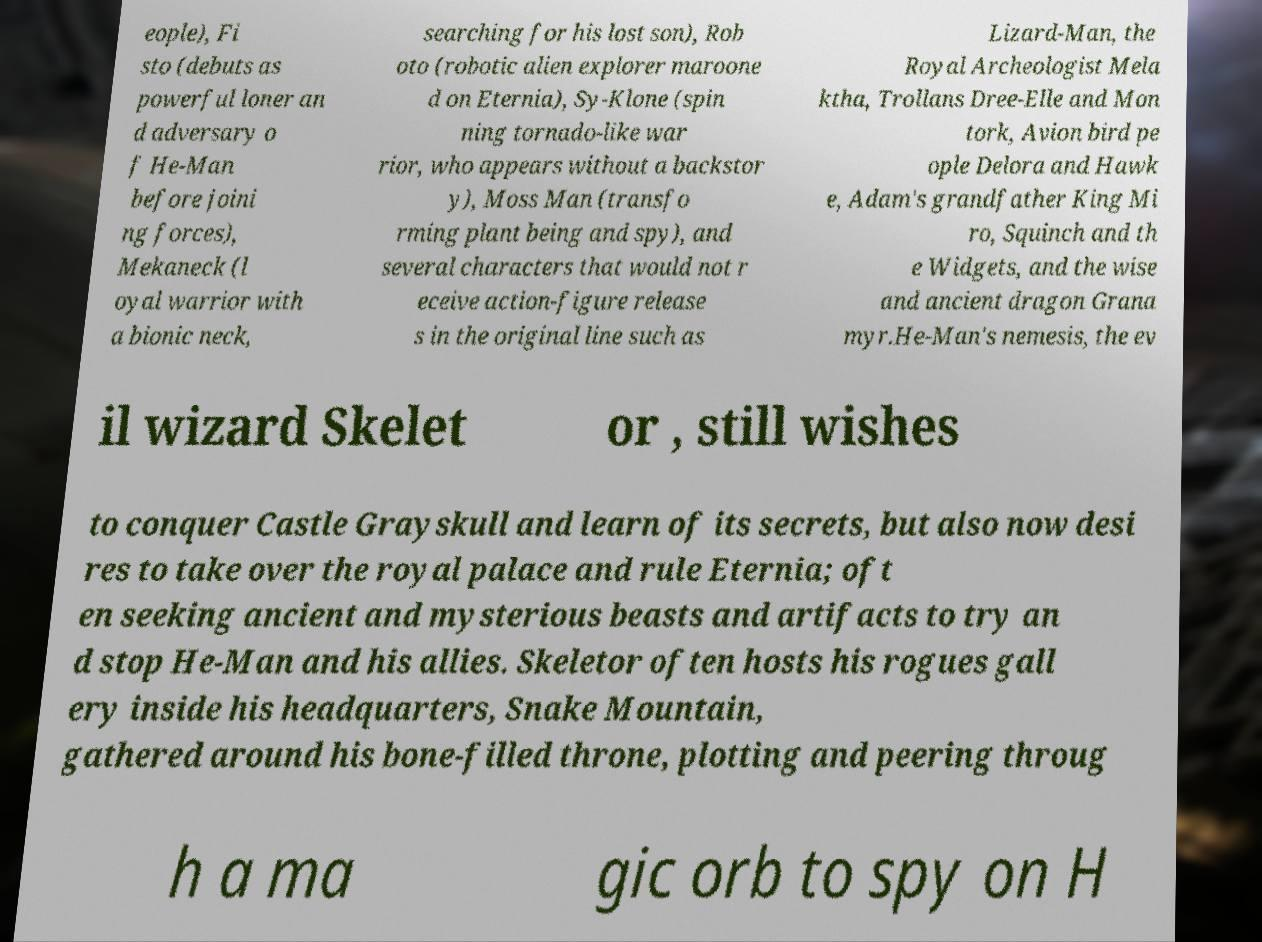What messages or text are displayed in this image? I need them in a readable, typed format. eople), Fi sto (debuts as powerful loner an d adversary o f He-Man before joini ng forces), Mekaneck (l oyal warrior with a bionic neck, searching for his lost son), Rob oto (robotic alien explorer maroone d on Eternia), Sy-Klone (spin ning tornado-like war rior, who appears without a backstor y), Moss Man (transfo rming plant being and spy), and several characters that would not r eceive action-figure release s in the original line such as Lizard-Man, the Royal Archeologist Mela ktha, Trollans Dree-Elle and Mon tork, Avion bird pe ople Delora and Hawk e, Adam's grandfather King Mi ro, Squinch and th e Widgets, and the wise and ancient dragon Grana myr.He-Man's nemesis, the ev il wizard Skelet or , still wishes to conquer Castle Grayskull and learn of its secrets, but also now desi res to take over the royal palace and rule Eternia; oft en seeking ancient and mysterious beasts and artifacts to try an d stop He-Man and his allies. Skeletor often hosts his rogues gall ery inside his headquarters, Snake Mountain, gathered around his bone-filled throne, plotting and peering throug h a ma gic orb to spy on H 